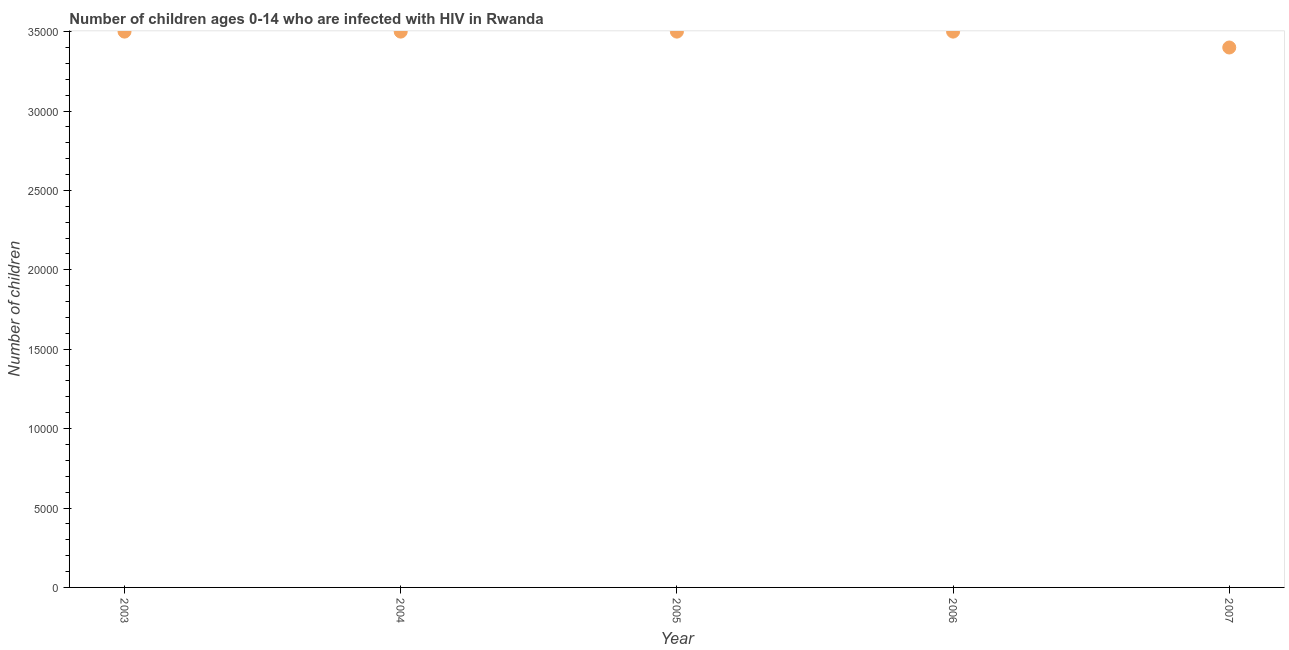What is the number of children living with hiv in 2003?
Your answer should be very brief. 3.50e+04. Across all years, what is the maximum number of children living with hiv?
Offer a terse response. 3.50e+04. Across all years, what is the minimum number of children living with hiv?
Provide a short and direct response. 3.40e+04. In which year was the number of children living with hiv maximum?
Provide a short and direct response. 2003. In which year was the number of children living with hiv minimum?
Offer a very short reply. 2007. What is the sum of the number of children living with hiv?
Make the answer very short. 1.74e+05. What is the difference between the number of children living with hiv in 2006 and 2007?
Ensure brevity in your answer.  1000. What is the average number of children living with hiv per year?
Offer a very short reply. 3.48e+04. What is the median number of children living with hiv?
Keep it short and to the point. 3.50e+04. In how many years, is the number of children living with hiv greater than 1000 ?
Make the answer very short. 5. Do a majority of the years between 2005 and 2006 (inclusive) have number of children living with hiv greater than 7000 ?
Your answer should be very brief. Yes. What is the ratio of the number of children living with hiv in 2004 to that in 2005?
Your answer should be compact. 1. Is the number of children living with hiv in 2006 less than that in 2007?
Ensure brevity in your answer.  No. What is the difference between the highest and the lowest number of children living with hiv?
Your answer should be compact. 1000. Does the number of children living with hiv monotonically increase over the years?
Provide a short and direct response. No. How many dotlines are there?
Offer a terse response. 1. How many years are there in the graph?
Offer a very short reply. 5. What is the difference between two consecutive major ticks on the Y-axis?
Provide a short and direct response. 5000. What is the title of the graph?
Your answer should be compact. Number of children ages 0-14 who are infected with HIV in Rwanda. What is the label or title of the Y-axis?
Your answer should be very brief. Number of children. What is the Number of children in 2003?
Provide a short and direct response. 3.50e+04. What is the Number of children in 2004?
Give a very brief answer. 3.50e+04. What is the Number of children in 2005?
Give a very brief answer. 3.50e+04. What is the Number of children in 2006?
Make the answer very short. 3.50e+04. What is the Number of children in 2007?
Your response must be concise. 3.40e+04. What is the difference between the Number of children in 2003 and 2004?
Make the answer very short. 0. What is the difference between the Number of children in 2004 and 2005?
Give a very brief answer. 0. What is the difference between the Number of children in 2004 and 2007?
Your response must be concise. 1000. What is the difference between the Number of children in 2005 and 2006?
Keep it short and to the point. 0. What is the difference between the Number of children in 2005 and 2007?
Keep it short and to the point. 1000. What is the ratio of the Number of children in 2003 to that in 2005?
Ensure brevity in your answer.  1. What is the ratio of the Number of children in 2003 to that in 2006?
Provide a short and direct response. 1. What is the ratio of the Number of children in 2003 to that in 2007?
Make the answer very short. 1.03. What is the ratio of the Number of children in 2004 to that in 2005?
Your answer should be very brief. 1. What is the ratio of the Number of children in 2004 to that in 2007?
Keep it short and to the point. 1.03. What is the ratio of the Number of children in 2005 to that in 2006?
Give a very brief answer. 1. 